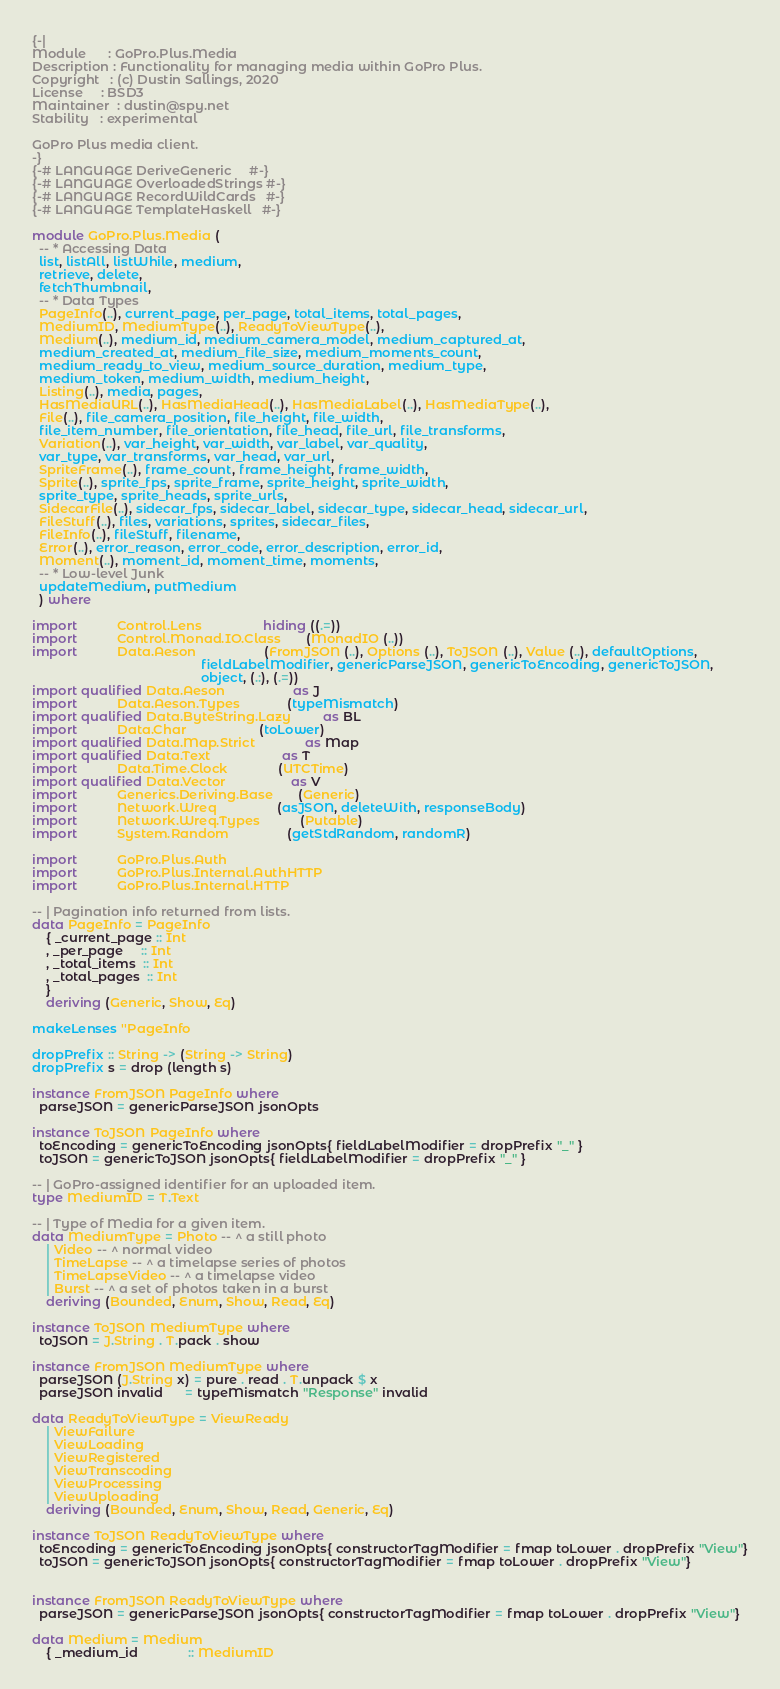Convert code to text. <code><loc_0><loc_0><loc_500><loc_500><_Haskell_>{-|
Module      : GoPro.Plus.Media
Description : Functionality for managing media within GoPro Plus.
Copyright   : (c) Dustin Sallings, 2020
License     : BSD3
Maintainer  : dustin@spy.net
Stability   : experimental

GoPro Plus media client.
-}
{-# LANGUAGE DeriveGeneric     #-}
{-# LANGUAGE OverloadedStrings #-}
{-# LANGUAGE RecordWildCards   #-}
{-# LANGUAGE TemplateHaskell   #-}

module GoPro.Plus.Media (
  -- * Accessing Data
  list, listAll, listWhile, medium,
  retrieve, delete,
  fetchThumbnail,
  -- * Data Types
  PageInfo(..), current_page, per_page, total_items, total_pages,
  MediumID, MediumType(..), ReadyToViewType(..),
  Medium(..), medium_id, medium_camera_model, medium_captured_at,
  medium_created_at, medium_file_size, medium_moments_count,
  medium_ready_to_view, medium_source_duration, medium_type,
  medium_token, medium_width, medium_height,
  Listing(..), media, pages,
  HasMediaURL(..), HasMediaHead(..), HasMediaLabel(..), HasMediaType(..),
  File(..), file_camera_position, file_height, file_width,
  file_item_number, file_orientation, file_head, file_url, file_transforms,
  Variation(..), var_height, var_width, var_label, var_quality,
  var_type, var_transforms, var_head, var_url,
  SpriteFrame(..), frame_count, frame_height, frame_width,
  Sprite(..), sprite_fps, sprite_frame, sprite_height, sprite_width,
  sprite_type, sprite_heads, sprite_urls,
  SidecarFile(..), sidecar_fps, sidecar_label, sidecar_type, sidecar_head, sidecar_url,
  FileStuff(..), files, variations, sprites, sidecar_files,
  FileInfo(..), fileStuff, filename,
  Error(..), error_reason, error_code, error_description, error_id,
  Moment(..), moment_id, moment_time, moments,
  -- * Low-level Junk
  updateMedium, putMedium
  ) where

import           Control.Lens                 hiding ((.=))
import           Control.Monad.IO.Class       (MonadIO (..))
import           Data.Aeson                   (FromJSON (..), Options (..), ToJSON (..), Value (..), defaultOptions,
                                               fieldLabelModifier, genericParseJSON, genericToEncoding, genericToJSON,
                                               object, (.:), (.=))
import qualified Data.Aeson                   as J
import           Data.Aeson.Types             (typeMismatch)
import qualified Data.ByteString.Lazy         as BL
import           Data.Char                    (toLower)
import qualified Data.Map.Strict              as Map
import qualified Data.Text                    as T
import           Data.Time.Clock              (UTCTime)
import qualified Data.Vector                  as V
import           Generics.Deriving.Base       (Generic)
import           Network.Wreq                 (asJSON, deleteWith, responseBody)
import           Network.Wreq.Types           (Putable)
import           System.Random                (getStdRandom, randomR)

import           GoPro.Plus.Auth
import           GoPro.Plus.Internal.AuthHTTP
import           GoPro.Plus.Internal.HTTP

-- | Pagination info returned from lists.
data PageInfo = PageInfo
    { _current_page :: Int
    , _per_page     :: Int
    , _total_items  :: Int
    , _total_pages  :: Int
    }
    deriving (Generic, Show, Eq)

makeLenses ''PageInfo

dropPrefix :: String -> (String -> String)
dropPrefix s = drop (length s)

instance FromJSON PageInfo where
  parseJSON = genericParseJSON jsonOpts

instance ToJSON PageInfo where
  toEncoding = genericToEncoding jsonOpts{ fieldLabelModifier = dropPrefix "_" }
  toJSON = genericToJSON jsonOpts{ fieldLabelModifier = dropPrefix "_" }

-- | GoPro-assigned identifier for an uploaded item.
type MediumID = T.Text

-- | Type of Media for a given item.
data MediumType = Photo -- ^ a still photo
    | Video -- ^ normal video
    | TimeLapse -- ^ a timelapse series of photos
    | TimeLapseVideo -- ^ a timelapse video
    | Burst -- ^ a set of photos taken in a burst
    deriving (Bounded, Enum, Show, Read, Eq)

instance ToJSON MediumType where
  toJSON = J.String . T.pack . show

instance FromJSON MediumType where
  parseJSON (J.String x) = pure . read . T.unpack $ x
  parseJSON invalid      = typeMismatch "Response" invalid

data ReadyToViewType = ViewReady
    | ViewFailure
    | ViewLoading
    | ViewRegistered
    | ViewTranscoding
    | ViewProcessing
    | ViewUploading
    deriving (Bounded, Enum, Show, Read, Generic, Eq)

instance ToJSON ReadyToViewType where
  toEncoding = genericToEncoding jsonOpts{ constructorTagModifier = fmap toLower . dropPrefix "View"}
  toJSON = genericToJSON jsonOpts{ constructorTagModifier = fmap toLower . dropPrefix "View"}


instance FromJSON ReadyToViewType where
  parseJSON = genericParseJSON jsonOpts{ constructorTagModifier = fmap toLower . dropPrefix "View"}

data Medium = Medium
    { _medium_id              :: MediumID</code> 